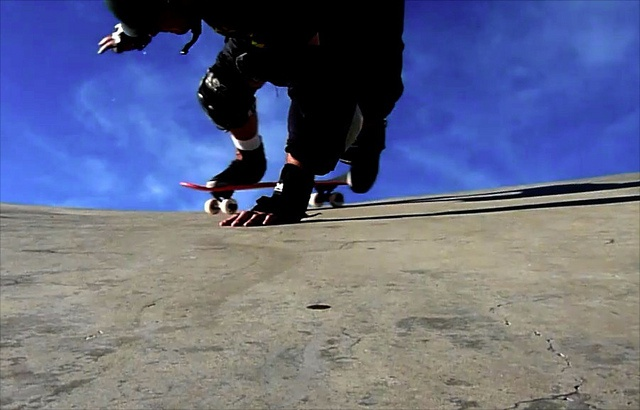Describe the objects in this image and their specific colors. I can see people in darkblue, black, gray, and navy tones and skateboard in darkblue, black, maroon, white, and gray tones in this image. 